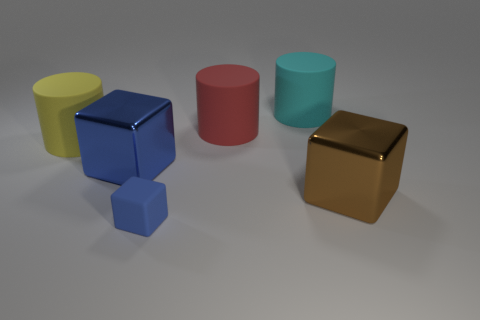Add 3 large yellow rubber cylinders. How many objects exist? 9 Subtract all large cubes. How many cubes are left? 1 Subtract all cyan cylinders. How many cylinders are left? 2 Subtract 1 cubes. How many cubes are left? 2 Subtract all rubber cylinders. Subtract all large rubber things. How many objects are left? 0 Add 4 big red rubber cylinders. How many big red rubber cylinders are left? 5 Add 6 big yellow matte cylinders. How many big yellow matte cylinders exist? 7 Subtract 0 brown cylinders. How many objects are left? 6 Subtract all brown blocks. Subtract all brown cylinders. How many blocks are left? 2 Subtract all gray balls. How many cyan cylinders are left? 1 